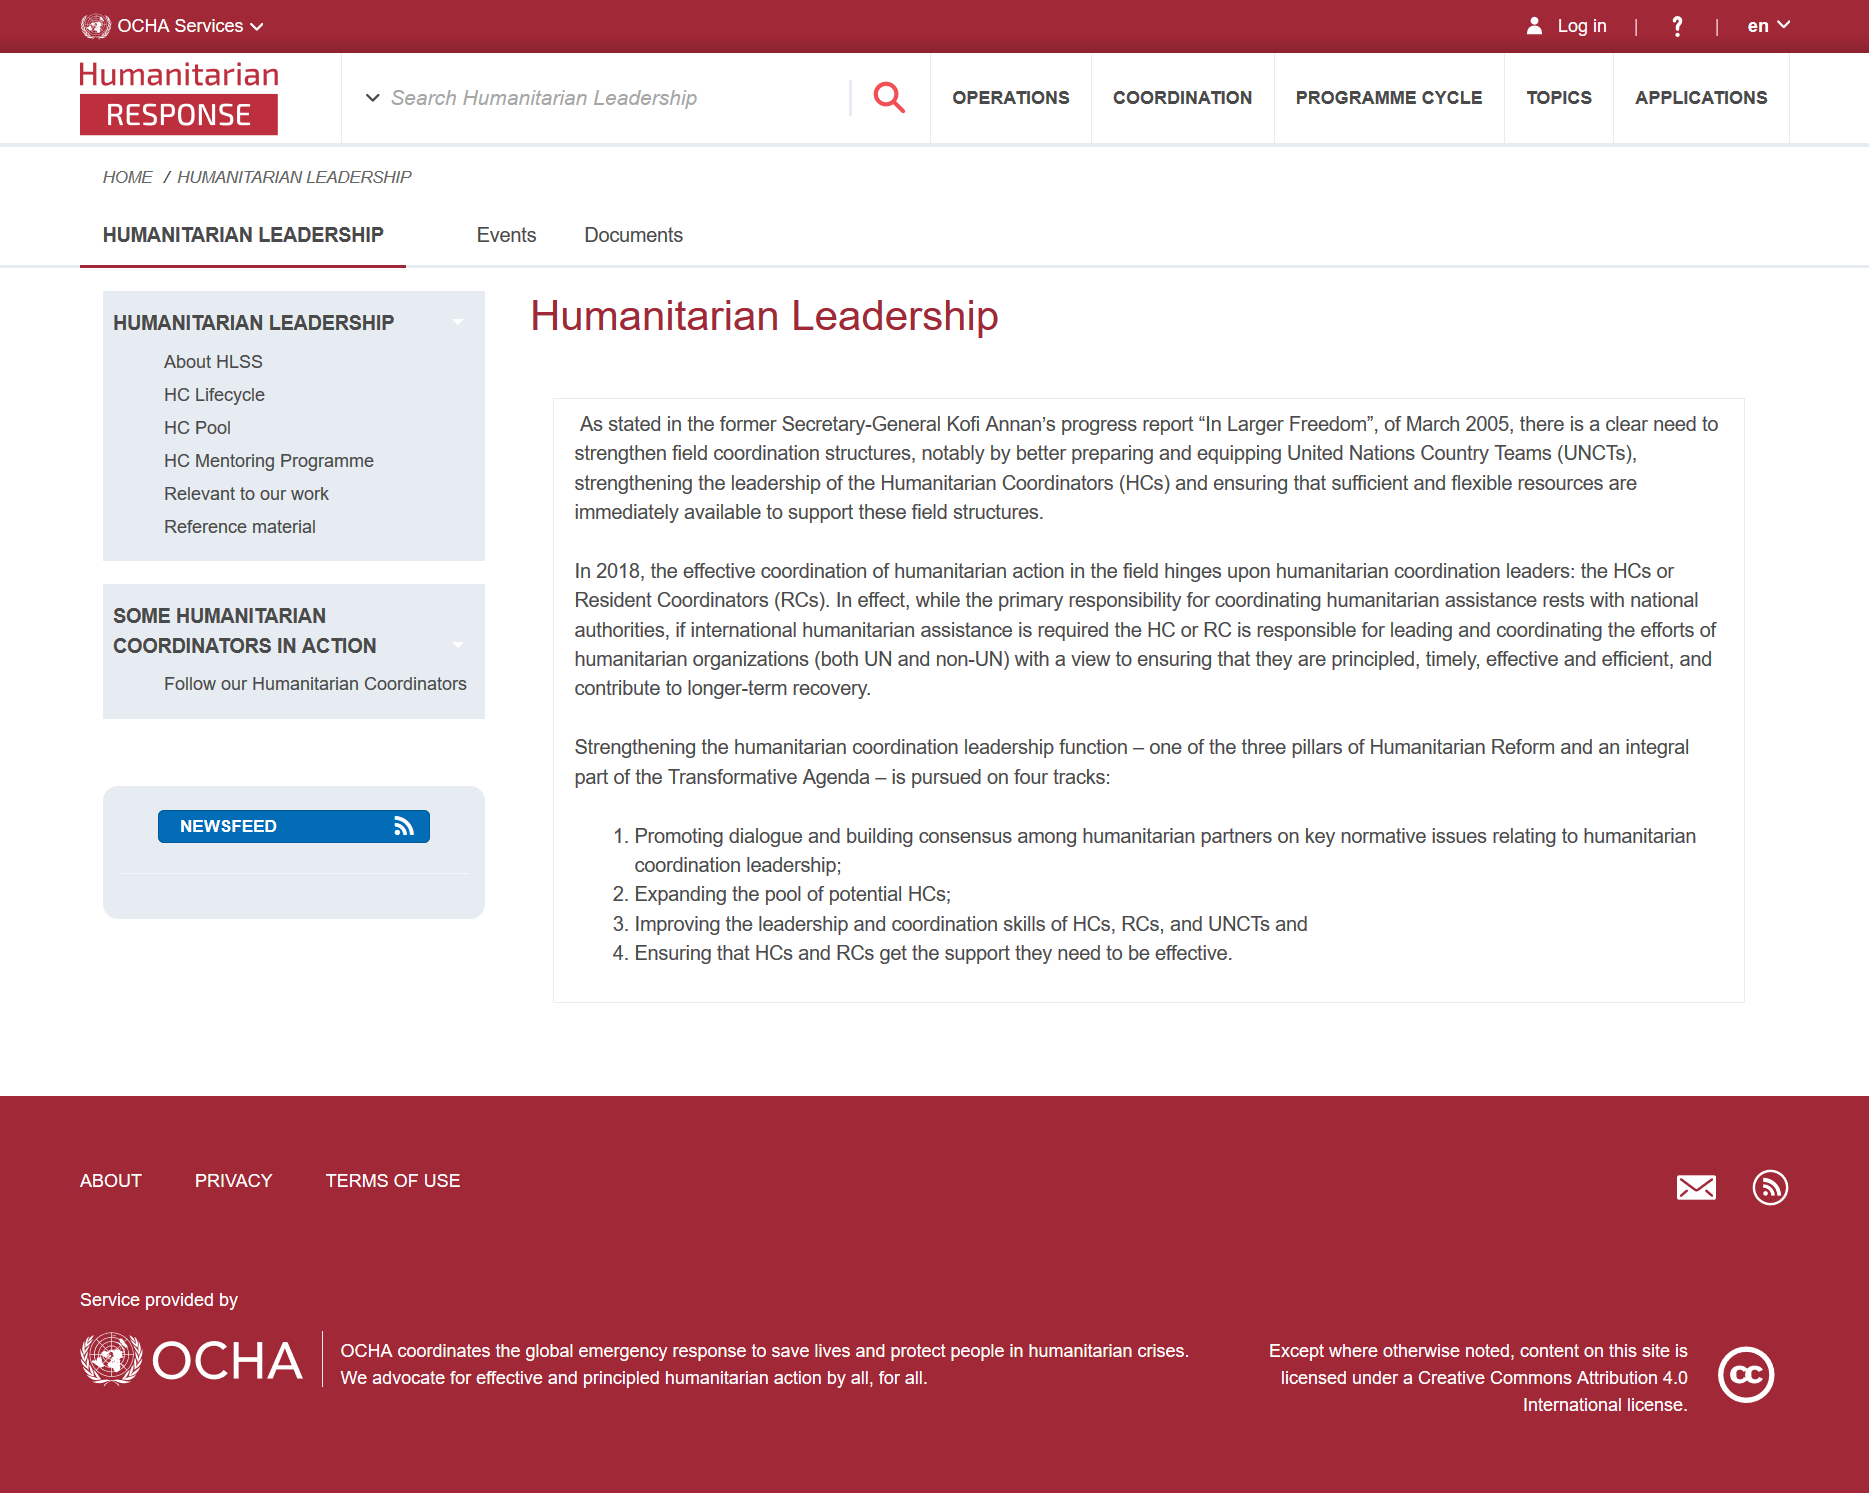Point out several critical features in this image. One way to strengthen field coordination structures under humanitarian leadership is by improving the preparation and equipment of United Nations Country Teams (UNCTs). Kofi Annan's progress report "In Larger Freedom" was written in March 2005. Humanitarian organizations should be guided by principles, act with dispatch, bring about positive results, and aim to achieve sustainable recovery. 